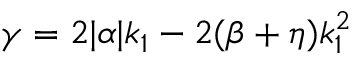Convert formula to latex. <formula><loc_0><loc_0><loc_500><loc_500>\gamma = 2 | \alpha | k _ { 1 } - 2 ( \beta + \eta ) k _ { 1 } ^ { 2 }</formula> 